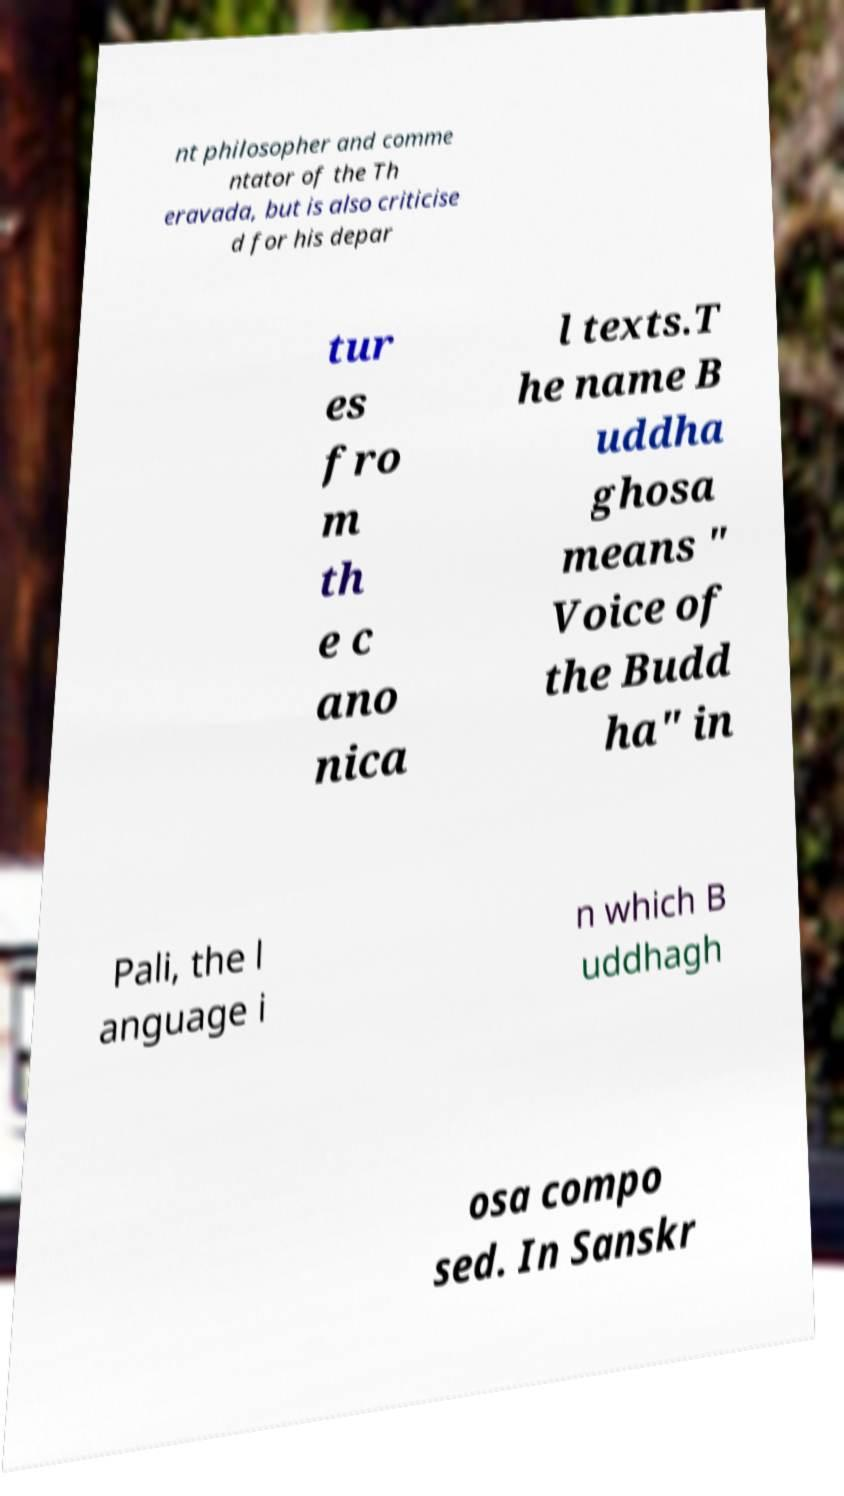Please read and relay the text visible in this image. What does it say? nt philosopher and comme ntator of the Th eravada, but is also criticise d for his depar tur es fro m th e c ano nica l texts.T he name B uddha ghosa means " Voice of the Budd ha" in Pali, the l anguage i n which B uddhagh osa compo sed. In Sanskr 